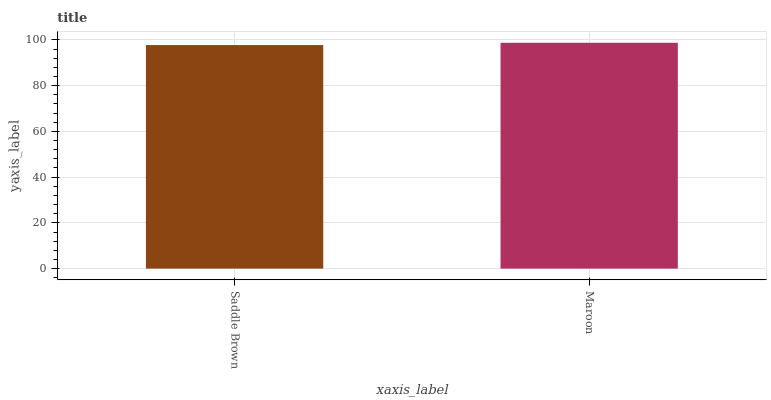Is Saddle Brown the minimum?
Answer yes or no. Yes. Is Maroon the maximum?
Answer yes or no. Yes. Is Maroon the minimum?
Answer yes or no. No. Is Maroon greater than Saddle Brown?
Answer yes or no. Yes. Is Saddle Brown less than Maroon?
Answer yes or no. Yes. Is Saddle Brown greater than Maroon?
Answer yes or no. No. Is Maroon less than Saddle Brown?
Answer yes or no. No. Is Maroon the high median?
Answer yes or no. Yes. Is Saddle Brown the low median?
Answer yes or no. Yes. Is Saddle Brown the high median?
Answer yes or no. No. Is Maroon the low median?
Answer yes or no. No. 